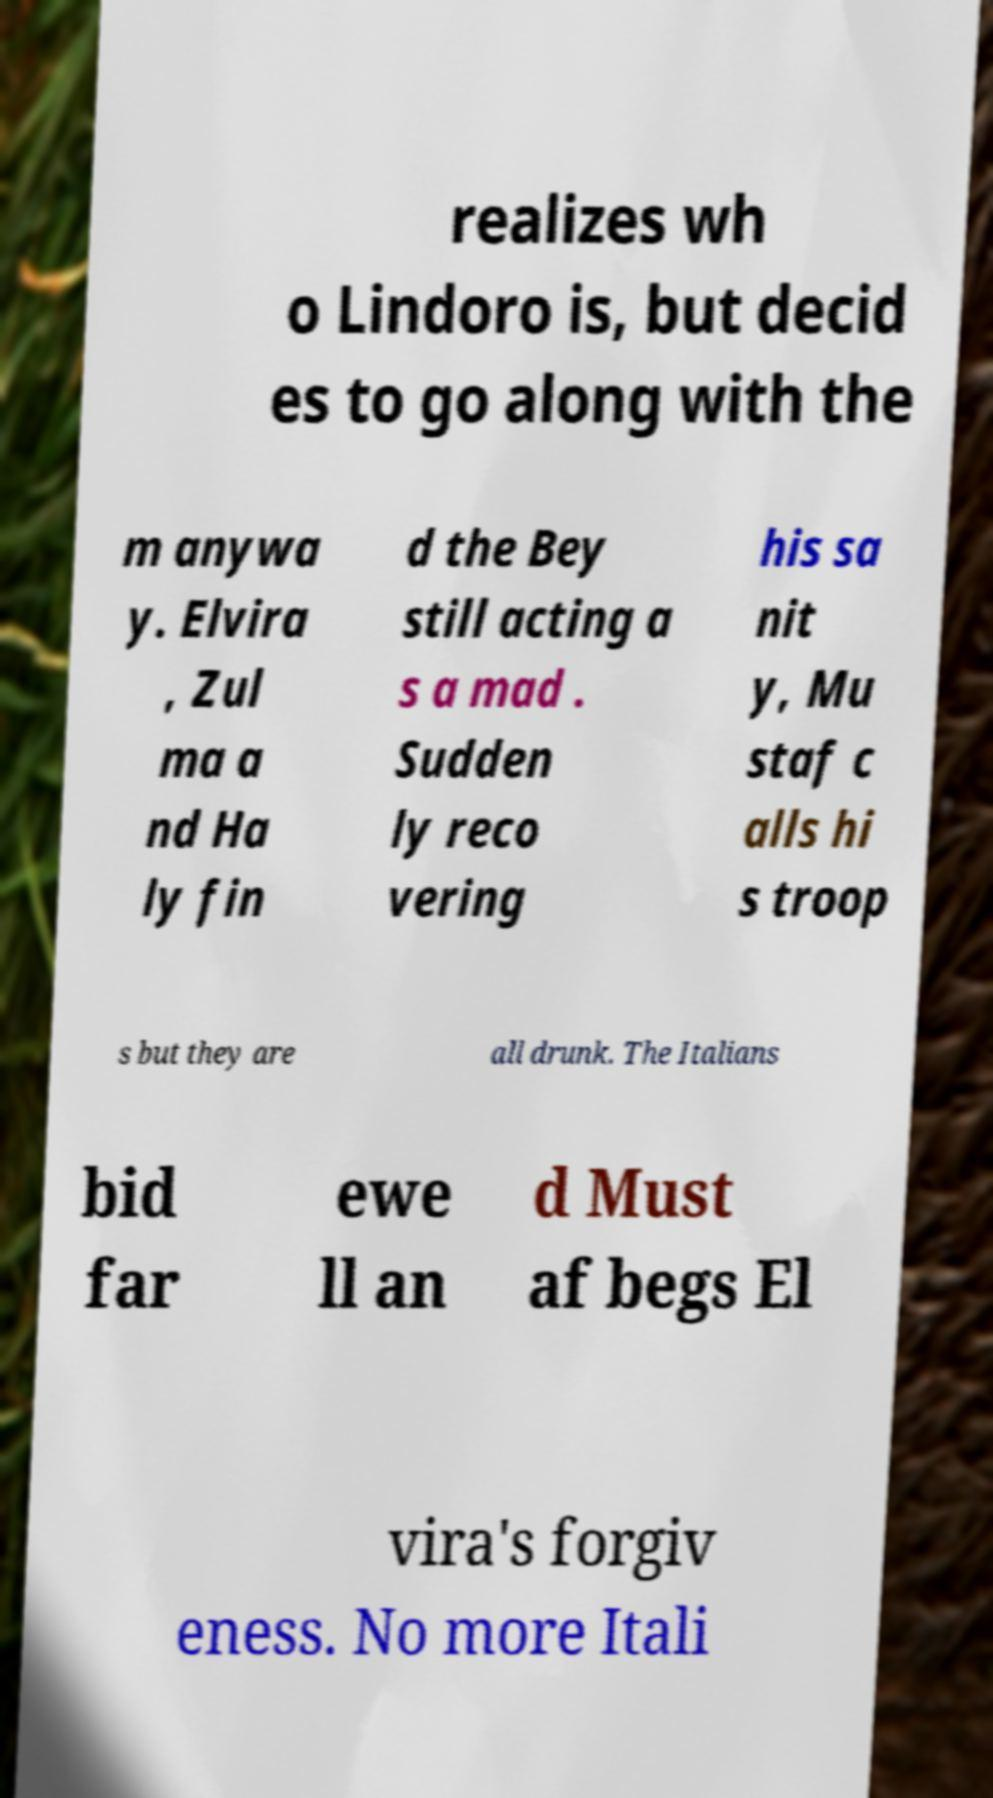What messages or text are displayed in this image? I need them in a readable, typed format. realizes wh o Lindoro is, but decid es to go along with the m anywa y. Elvira , Zul ma a nd Ha ly fin d the Bey still acting a s a mad . Sudden ly reco vering his sa nit y, Mu staf c alls hi s troop s but they are all drunk. The Italians bid far ewe ll an d Must af begs El vira's forgiv eness. No more Itali 